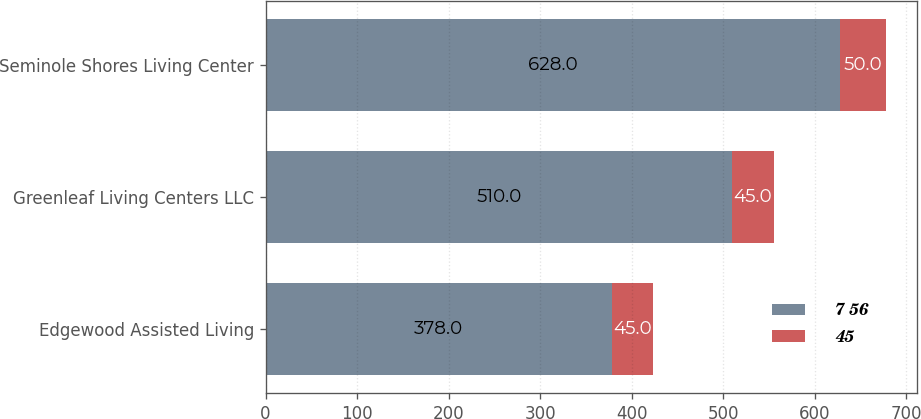<chart> <loc_0><loc_0><loc_500><loc_500><stacked_bar_chart><ecel><fcel>Edgewood Assisted Living<fcel>Greenleaf Living Centers LLC<fcel>Seminole Shores Living Center<nl><fcel>7 56<fcel>378<fcel>510<fcel>628<nl><fcel>45<fcel>45<fcel>45<fcel>50<nl></chart> 